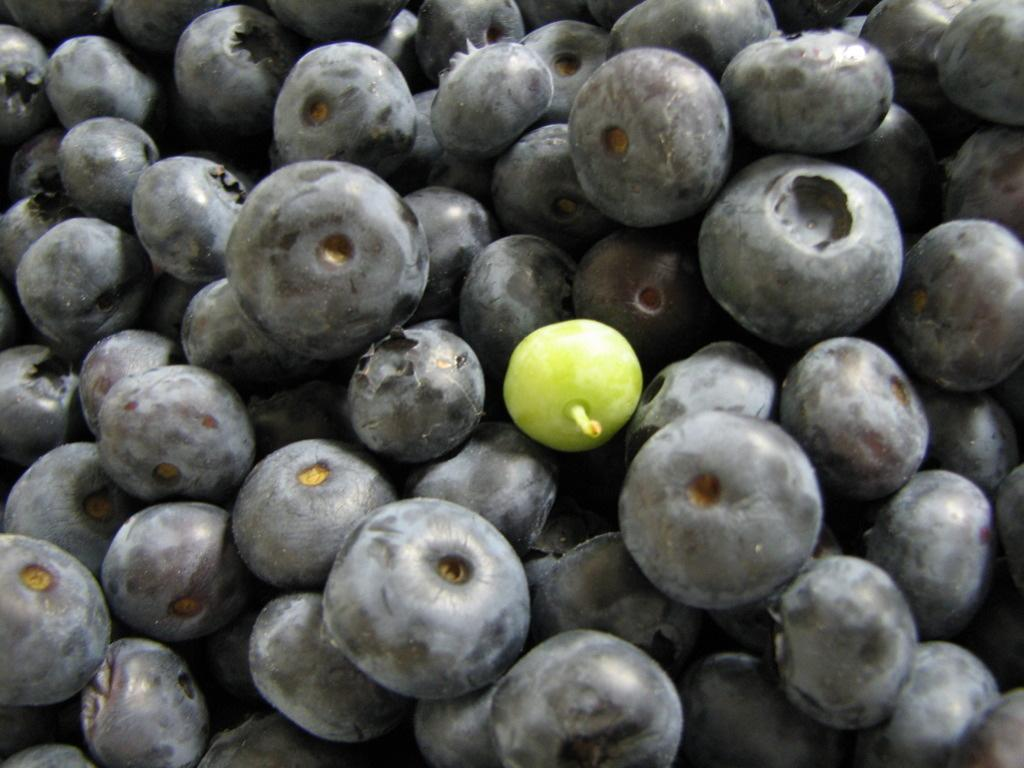What colors are the fruits in the image? The fruits in the image have black and green colors. What type of curtain can be seen hanging near the coast in the image? There is no curtain or coast present in the image; it only features black and green color fruits. 